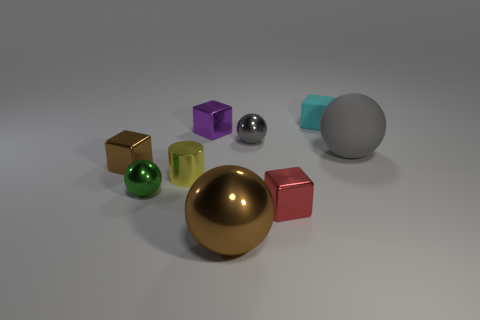Subtract all rubber cubes. How many cubes are left? 3 Subtract all cyan blocks. How many gray balls are left? 2 Subtract all brown balls. How many balls are left? 3 Subtract 0 purple cylinders. How many objects are left? 9 Subtract all balls. How many objects are left? 5 Subtract 2 spheres. How many spheres are left? 2 Subtract all red cylinders. Subtract all green cubes. How many cylinders are left? 1 Subtract all green metal balls. Subtract all yellow metallic things. How many objects are left? 7 Add 3 gray metallic objects. How many gray metallic objects are left? 4 Add 1 small yellow cylinders. How many small yellow cylinders exist? 2 